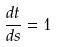<formula> <loc_0><loc_0><loc_500><loc_500>\frac { d t } { d s } = 1</formula> 